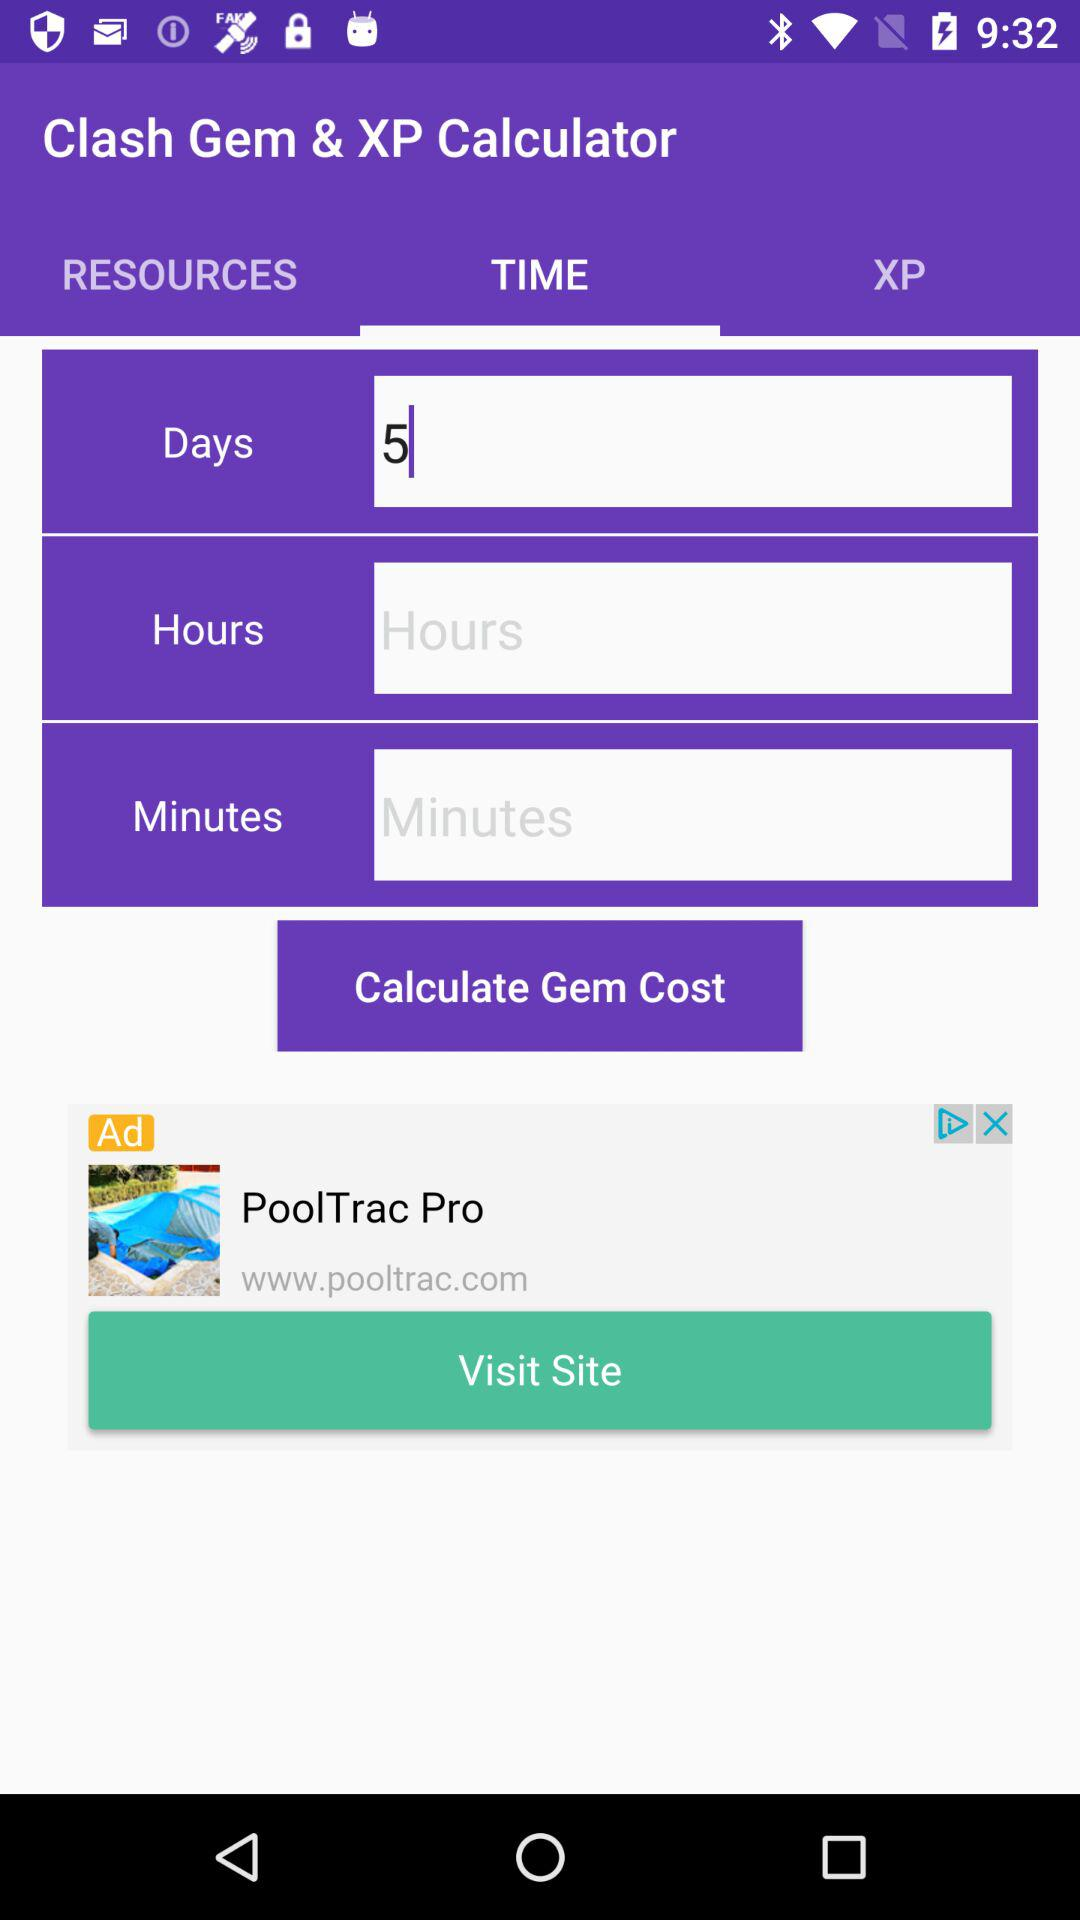What is the app name? The app name is "Clash Gem & XP Calculator". 